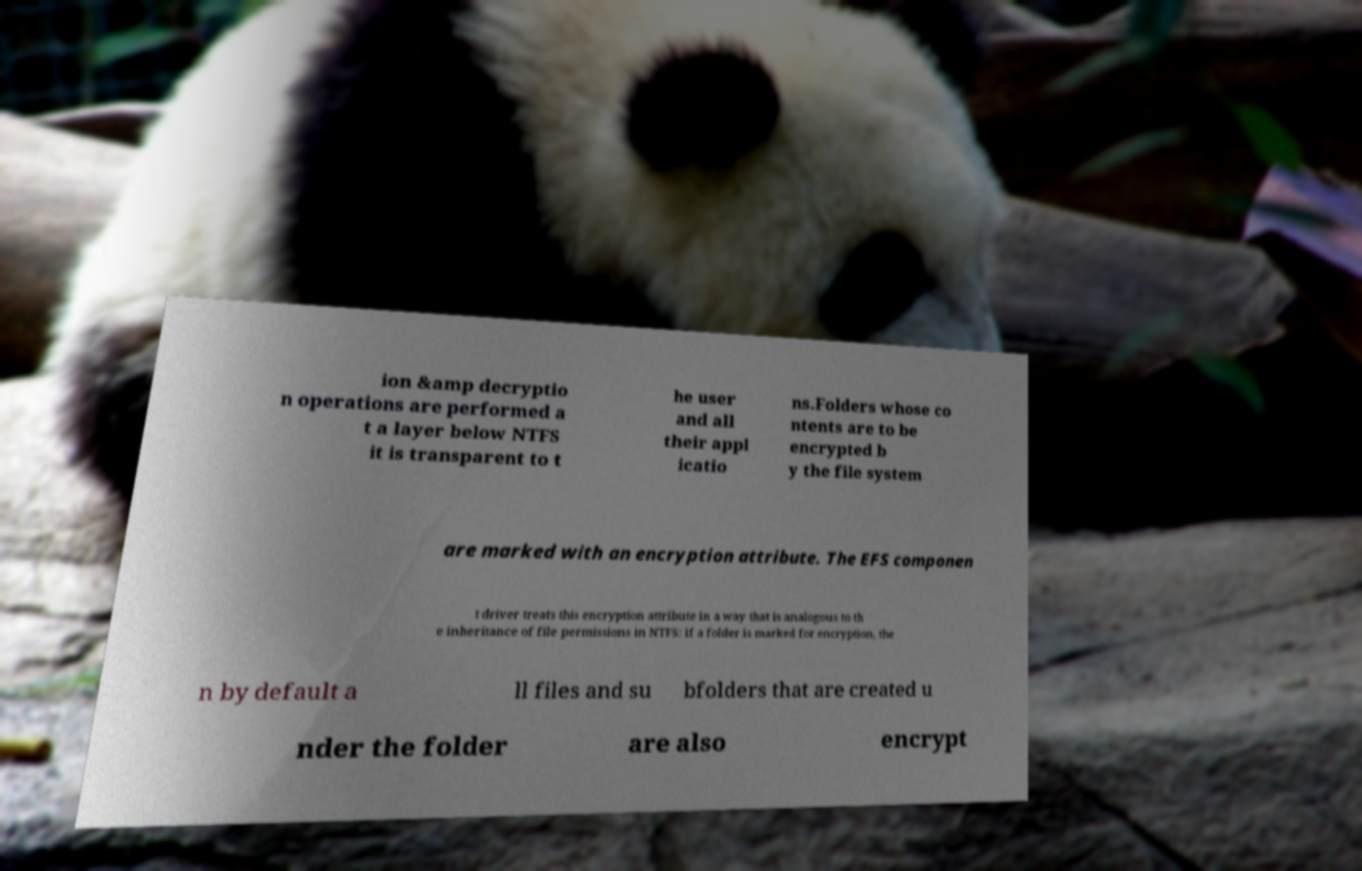Could you assist in decoding the text presented in this image and type it out clearly? ion &amp decryptio n operations are performed a t a layer below NTFS it is transparent to t he user and all their appl icatio ns.Folders whose co ntents are to be encrypted b y the file system are marked with an encryption attribute. The EFS componen t driver treats this encryption attribute in a way that is analogous to th e inheritance of file permissions in NTFS: if a folder is marked for encryption, the n by default a ll files and su bfolders that are created u nder the folder are also encrypt 